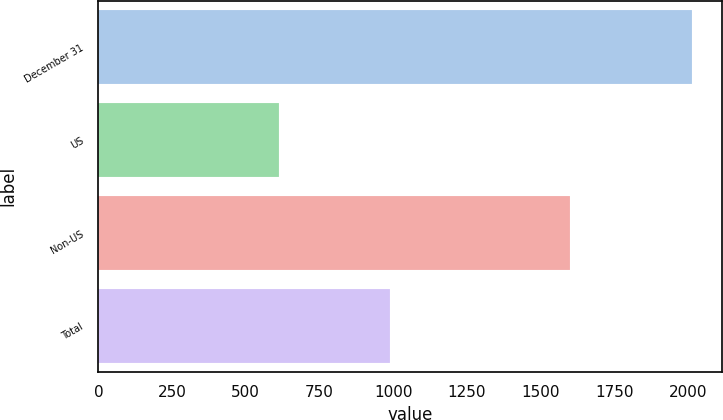Convert chart. <chart><loc_0><loc_0><loc_500><loc_500><bar_chart><fcel>December 31<fcel>US<fcel>Non-US<fcel>Total<nl><fcel>2015<fcel>612<fcel>1601<fcel>989<nl></chart> 